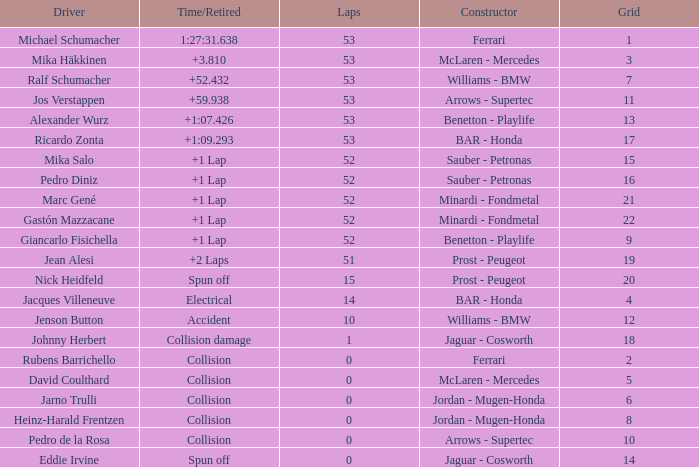Parse the full table. {'header': ['Driver', 'Time/Retired', 'Laps', 'Constructor', 'Grid'], 'rows': [['Michael Schumacher', '1:27:31.638', '53', 'Ferrari', '1'], ['Mika Häkkinen', '+3.810', '53', 'McLaren - Mercedes', '3'], ['Ralf Schumacher', '+52.432', '53', 'Williams - BMW', '7'], ['Jos Verstappen', '+59.938', '53', 'Arrows - Supertec', '11'], ['Alexander Wurz', '+1:07.426', '53', 'Benetton - Playlife', '13'], ['Ricardo Zonta', '+1:09.293', '53', 'BAR - Honda', '17'], ['Mika Salo', '+1 Lap', '52', 'Sauber - Petronas', '15'], ['Pedro Diniz', '+1 Lap', '52', 'Sauber - Petronas', '16'], ['Marc Gené', '+1 Lap', '52', 'Minardi - Fondmetal', '21'], ['Gastón Mazzacane', '+1 Lap', '52', 'Minardi - Fondmetal', '22'], ['Giancarlo Fisichella', '+1 Lap', '52', 'Benetton - Playlife', '9'], ['Jean Alesi', '+2 Laps', '51', 'Prost - Peugeot', '19'], ['Nick Heidfeld', 'Spun off', '15', 'Prost - Peugeot', '20'], ['Jacques Villeneuve', 'Electrical', '14', 'BAR - Honda', '4'], ['Jenson Button', 'Accident', '10', 'Williams - BMW', '12'], ['Johnny Herbert', 'Collision damage', '1', 'Jaguar - Cosworth', '18'], ['Rubens Barrichello', 'Collision', '0', 'Ferrari', '2'], ['David Coulthard', 'Collision', '0', 'McLaren - Mercedes', '5'], ['Jarno Trulli', 'Collision', '0', 'Jordan - Mugen-Honda', '6'], ['Heinz-Harald Frentzen', 'Collision', '0', 'Jordan - Mugen-Honda', '8'], ['Pedro de la Rosa', 'Collision', '0', 'Arrows - Supertec', '10'], ['Eddie Irvine', 'Spun off', '0', 'Jaguar - Cosworth', '14']]} What is the grid number with less than 52 laps and a Time/Retired of collision, and a Constructor of arrows - supertec? 1.0. 